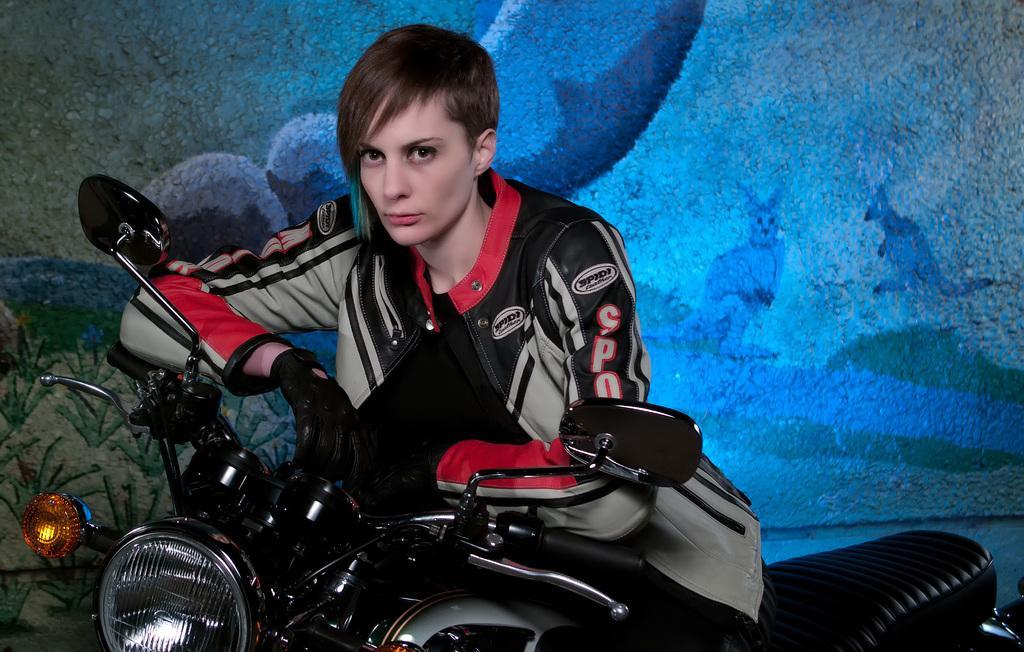Please provide a concise description of this image. In front of the image there is a person sitting on the bike. Behind her there is a painting on the wall. 